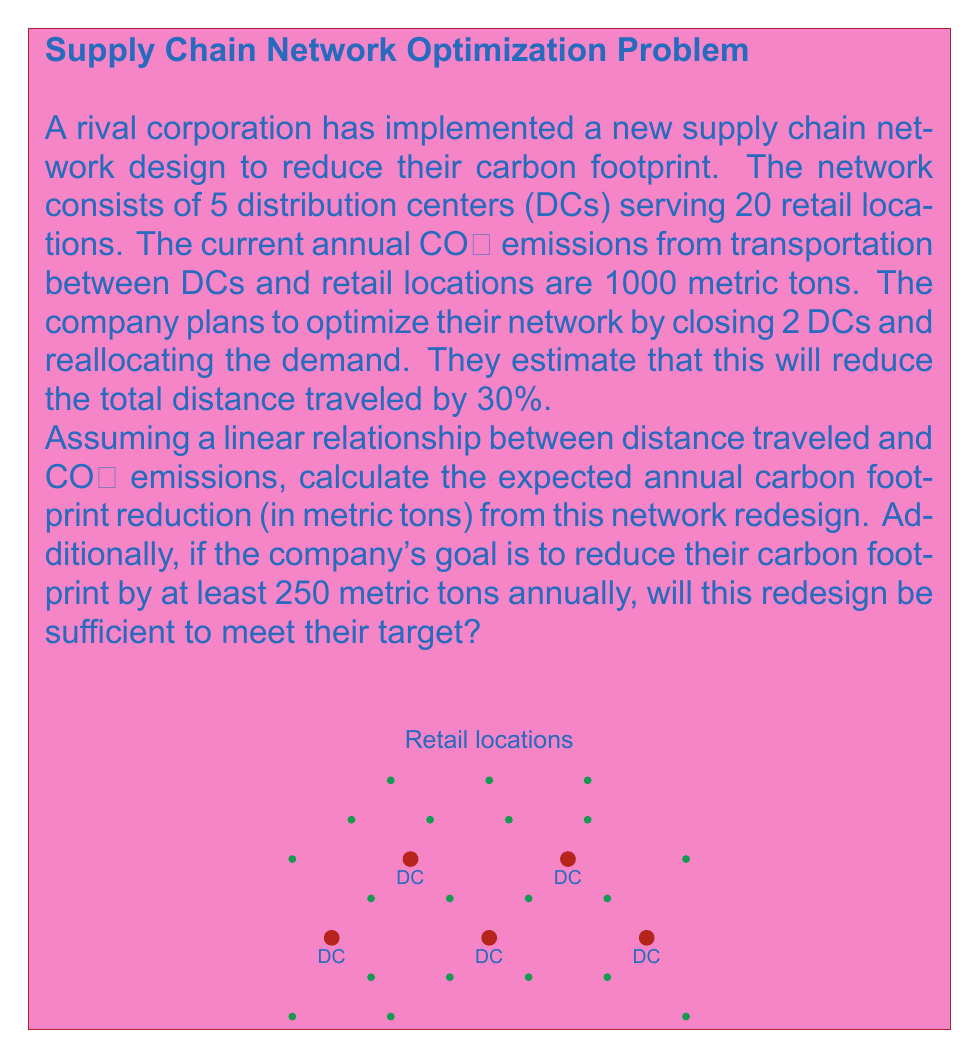Could you help me with this problem? Let's approach this problem step-by-step:

1) First, we need to understand the relationship between distance traveled and CO₂ emissions. The question states that there's a linear relationship, which means we can express it as:

   $$\text{CO₂ emissions} \propto \text{Distance traveled}$$

2) We're given that the current annual CO₂ emissions are 1000 metric tons, and the company plans to reduce the total distance traveled by 30%.

3) To calculate the new CO₂ emissions after the network redesign, we can use the following equation:

   $$\text{New CO₂ emissions} = \text{Current CO₂ emissions} \times (1 - \text{Distance reduction percentage})$$

4) Plugging in the values:

   $$\text{New CO₂ emissions} = 1000 \times (1 - 0.30) = 1000 \times 0.70 = 700 \text{ metric tons}$$

5) To find the carbon footprint reduction, we subtract the new emissions from the current emissions:

   $$\text{Carbon footprint reduction} = \text{Current CO₂ emissions} - \text{New CO₂ emissions}$$
   $$= 1000 - 700 = 300 \text{ metric tons}$$

6) To determine if this redesign meets the company's goal, we compare the calculated reduction to the target:

   $$300 \text{ metric tons} > 250 \text{ metric tons}$$

   The calculated reduction exceeds the target, so the redesign is sufficient to meet the company's goal.
Answer: 300 metric tons; Yes, the redesign is sufficient. 